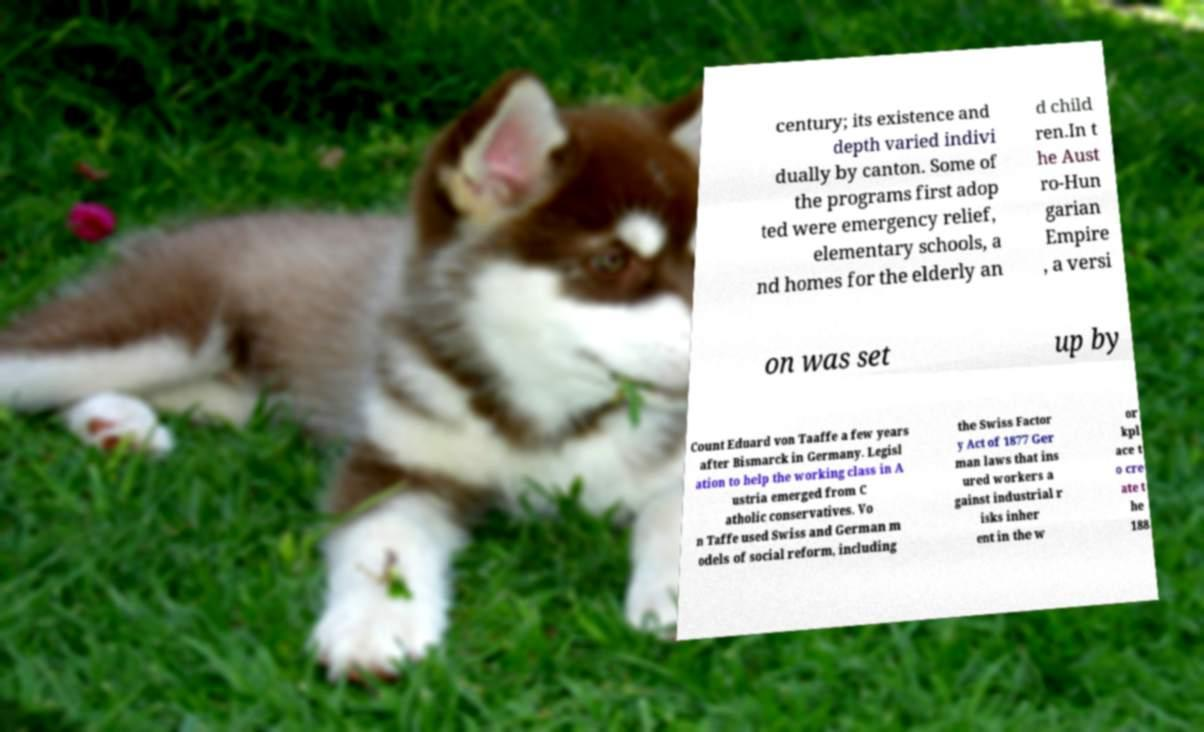Please read and relay the text visible in this image. What does it say? century; its existence and depth varied indivi dually by canton. Some of the programs first adop ted were emergency relief, elementary schools, a nd homes for the elderly an d child ren.In t he Aust ro-Hun garian Empire , a versi on was set up by Count Eduard von Taaffe a few years after Bismarck in Germany. Legisl ation to help the working class in A ustria emerged from C atholic conservatives. Vo n Taffe used Swiss and German m odels of social reform, including the Swiss Factor y Act of 1877 Ger man laws that ins ured workers a gainst industrial r isks inher ent in the w or kpl ace t o cre ate t he 188 